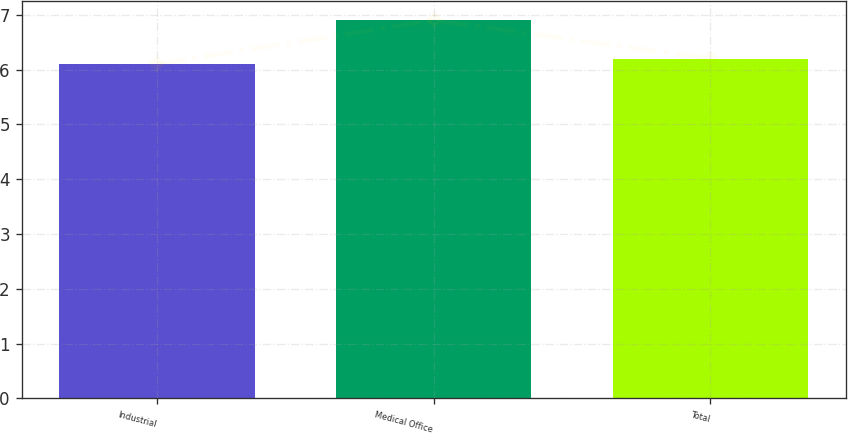<chart> <loc_0><loc_0><loc_500><loc_500><bar_chart><fcel>Industrial<fcel>Medical Office<fcel>Total<nl><fcel>6.1<fcel>6.9<fcel>6.2<nl></chart> 